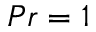<formula> <loc_0><loc_0><loc_500><loc_500>P r = 1</formula> 